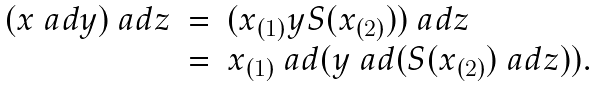<formula> <loc_0><loc_0><loc_500><loc_500>\begin{array} { r c l } ( x \ a d y ) \ a d z & = & ( x _ { ( 1 ) } y S ( x _ { ( 2 ) } ) ) \ a d z \\ & = & x _ { ( 1 ) } \ a d ( y \ a d ( S ( x _ { ( 2 ) } ) \ a d z ) ) . \end{array}</formula> 